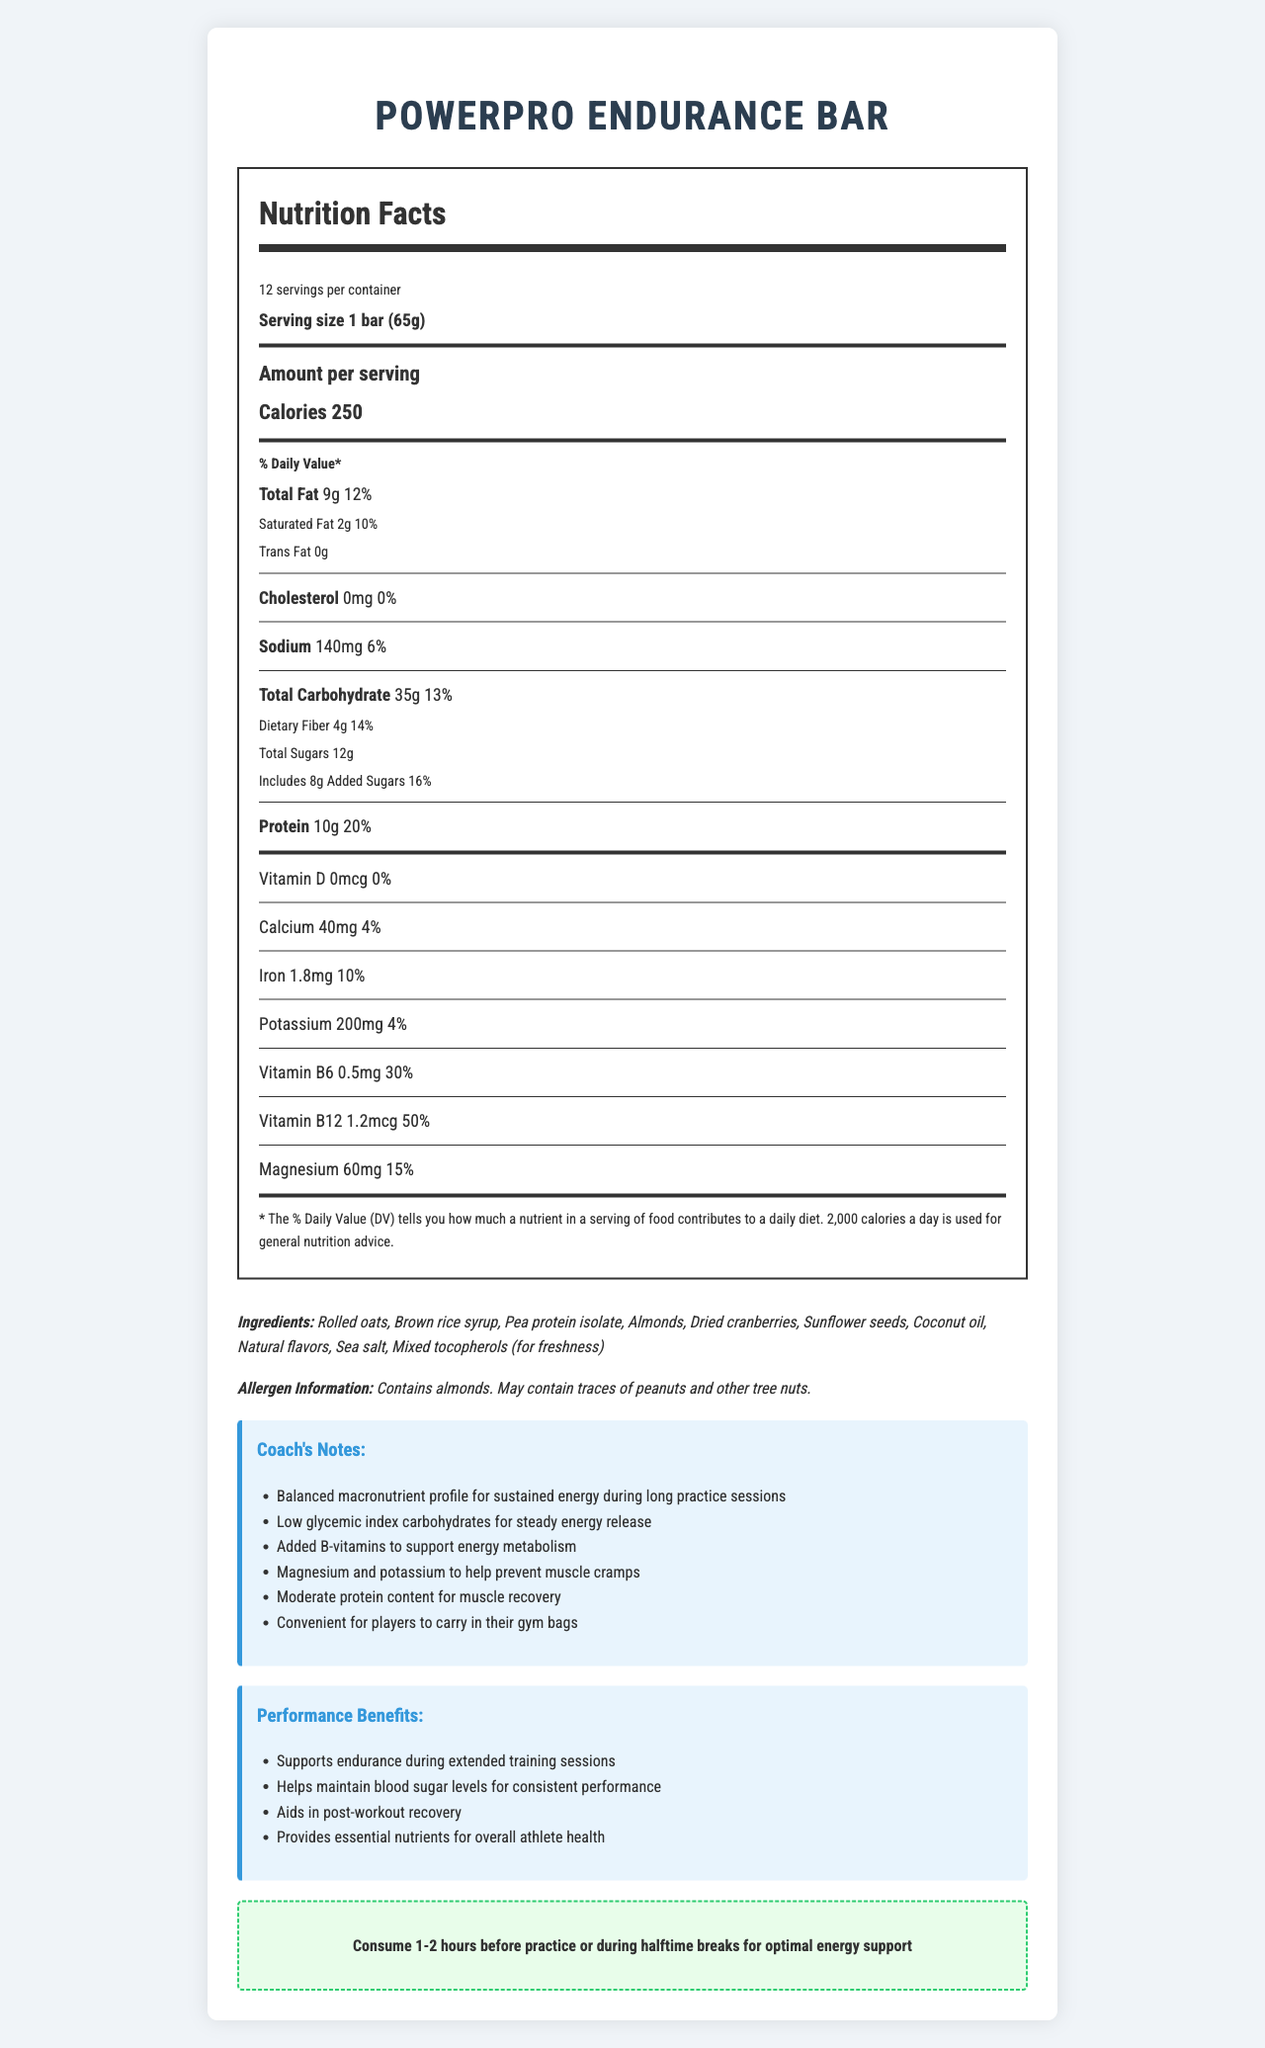how many calories are in one PowerPro Endurance Bar? The document states that each serving contains 250 calories, and a serving size is 1 bar.
Answer: 250 What is the serving size of the PowerPro Endurance Bar? The serving size is listed as "1 bar (65g)" in the document.
Answer: 1 bar (65g) What is the daily value percentage for protein in the PowerPro Endurance Bar? The document shows that the daily value percentage for protein is 20%.
Answer: 20% What are the added sugars in one PowerPro Endurance Bar, and what is their daily value percentage? The document notes that there are 8g of added sugars, which is 16% of the daily value.
Answer: 8g, 16% What ingredient is used to keep the PowerPro Endurance Bar fresh? The ingredients list includes "Mixed tocopherols (for freshness)."
Answer: Mixed tocopherols Which of the following nutrients in the PowerPro Endurance Bar has the highest daily value percentage? A. Vitamin B6 B. Iron C. Potassium D. Magnesium The daily value percentage for Vitamin B6 is 30%, which is higher than Iron (10%), Potassium (4%), and Magnesium (15%).
Answer: A. Vitamin B6 How much sodium is in one PowerPro Endurance Bar? A. 100mg B. 140mg C. 200mg D. 250mg The sodium content is listed as 140mg in the document.
Answer: B. 140mg Is there any cholesterol in the PowerPro Endurance Bar? The document lists the cholesterol content as 0mg and 0% daily value.
Answer: No Does the PowerPro Endurance Bar contain any peanuts? The allergen information mentions that the bar may contain traces of peanuts and other tree nuts.
Answer: May contain traces Summarize the nutritional benefits of the PowerPro Endurance Bar based on the coach's notes and performance benefits sections. The document details that the bar's nutritional profile is optimized to provide long-lasting energy, support muscle recovery, and maintain overall health during extended training sessions. The ingredients and added nutrients, like B-vitamins, magnesium, and potassium, as well as the balanced macronutrient content, are designed to enhance athletic performance and recovery.
Answer: The PowerPro Endurance Bar is designed to provide sustained energy with a balanced macronutrient profile, featuring low glycemic index carbohydrates for steady energy release and added B-vitamins to support energy metabolism. It includes magnesium and potassium to help prevent muscle cramps and has a moderate protein content for muscle recovery. It's also convenient for athletes to carry and supports endurance, performance consistency, post-workout recovery, and overall athlete health. What is the total carbohydrate content per serving in the PowerPro Endurance Bar? The document states that each serving contains 35g of total carbohydrates.
Answer: 35g What is the main ingredient in the PowerPro Endurance Bar? The first ingredient listed in the ingredients section is rolled oats.
Answer: Rolled oats What is the recommended usage of the PowerPro Endurance Bar? The recommended usage section in the document suggests consuming the bar 1-2 hours before practice or during halftime breaks.
Answer: Consume 1-2 hours before practice or during halftime breaks for optimal energy support How many servings are there in one container of PowerPro Endurance Bars? The document states that there are 12 servings per container.
Answer: 12 What is the difference between total sugars and added sugars in one PowerPro Endurance Bar? The document mentions 12g of total sugars, which includes 8g of added sugars.
Answer: Total sugars: 12g, Added sugars: 8g How does the PowerPro Endurance Bar help prevent muscle cramps? The coach's notes highlight that the bar contains magnesium and potassium, which help prevent muscle cramps.
Answer: Contains magnesium and potassium Does the PowerPro Endurance Bar contain dairy? The ingredients list does not specify any dairy products directly, but it also does not certify that it is dairy-free.
Answer: Cannot be determined 